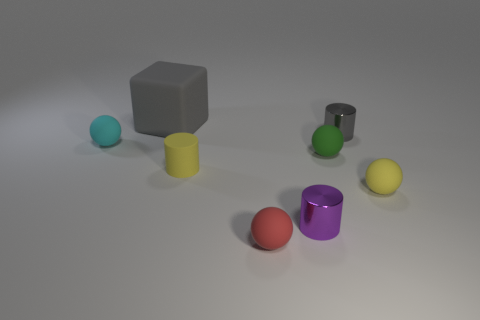Add 2 matte spheres. How many objects exist? 10 Subtract all green spheres. How many spheres are left? 3 Subtract all gray cylinders. How many cylinders are left? 2 Subtract 1 gray cubes. How many objects are left? 7 Subtract all cubes. How many objects are left? 7 Subtract 1 cubes. How many cubes are left? 0 Subtract all gray spheres. Subtract all green cylinders. How many spheres are left? 4 Subtract all purple spheres. How many brown cylinders are left? 0 Subtract all small shiny cylinders. Subtract all red things. How many objects are left? 5 Add 6 gray cubes. How many gray cubes are left? 7 